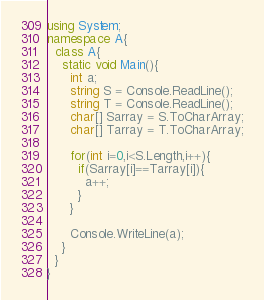Convert code to text. <code><loc_0><loc_0><loc_500><loc_500><_C#_>using System;
namespace A{
  class A{
    static void Main(){
      int a;
      string S = Console.ReadLine();
      string T = Console.ReadLine();
      char[] Sarray = S.ToCharArray;
      char[] Tarray = T.ToCharArray;
      
      for(int i=0,i<S.Length,i++){
        if(Sarray[i]==Tarray[i]){
          a++;
        }
      }
      
      Console.WriteLine(a);
    }
  }
}
</code> 